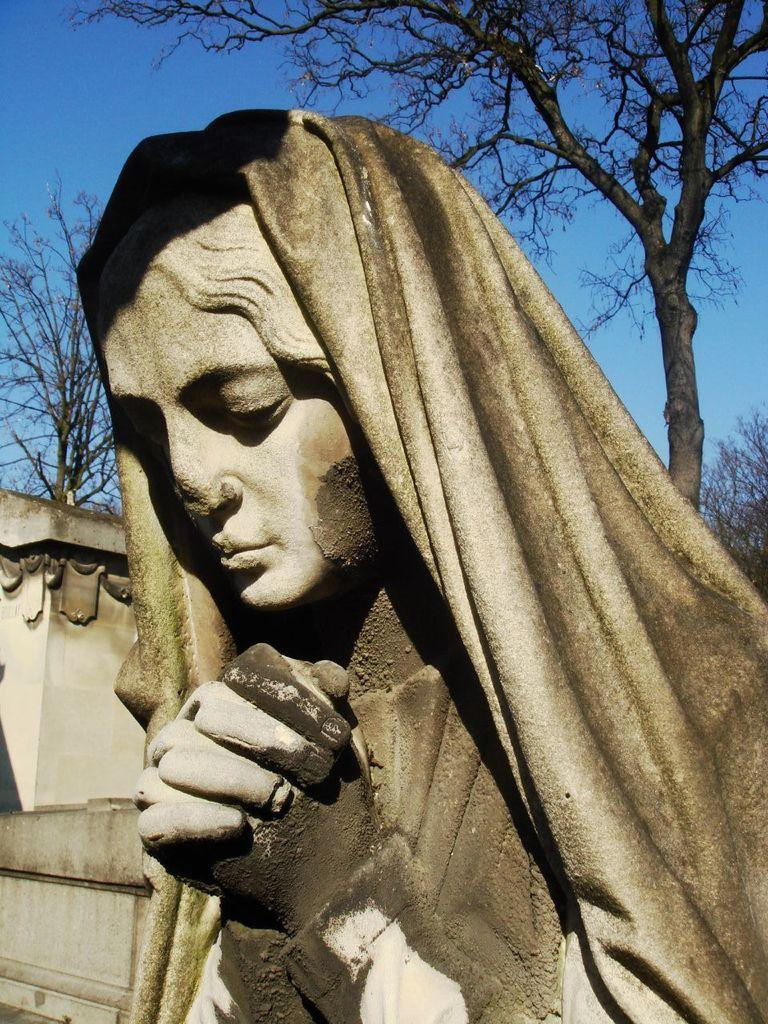What is the main subject of the image? There is a statue of a person in the image. What is located in the foreground of the image? There is a wall in the foreground of the image. What can be seen in the background of the image? Trees are visible in the background of the image. What is visible at the top of the image? The sky is visible at the top of the image. What historical event is the statue commemorating in the image? The provided facts do not mention any historical event related to the statue, so we cannot determine what event it might be commemorating. 